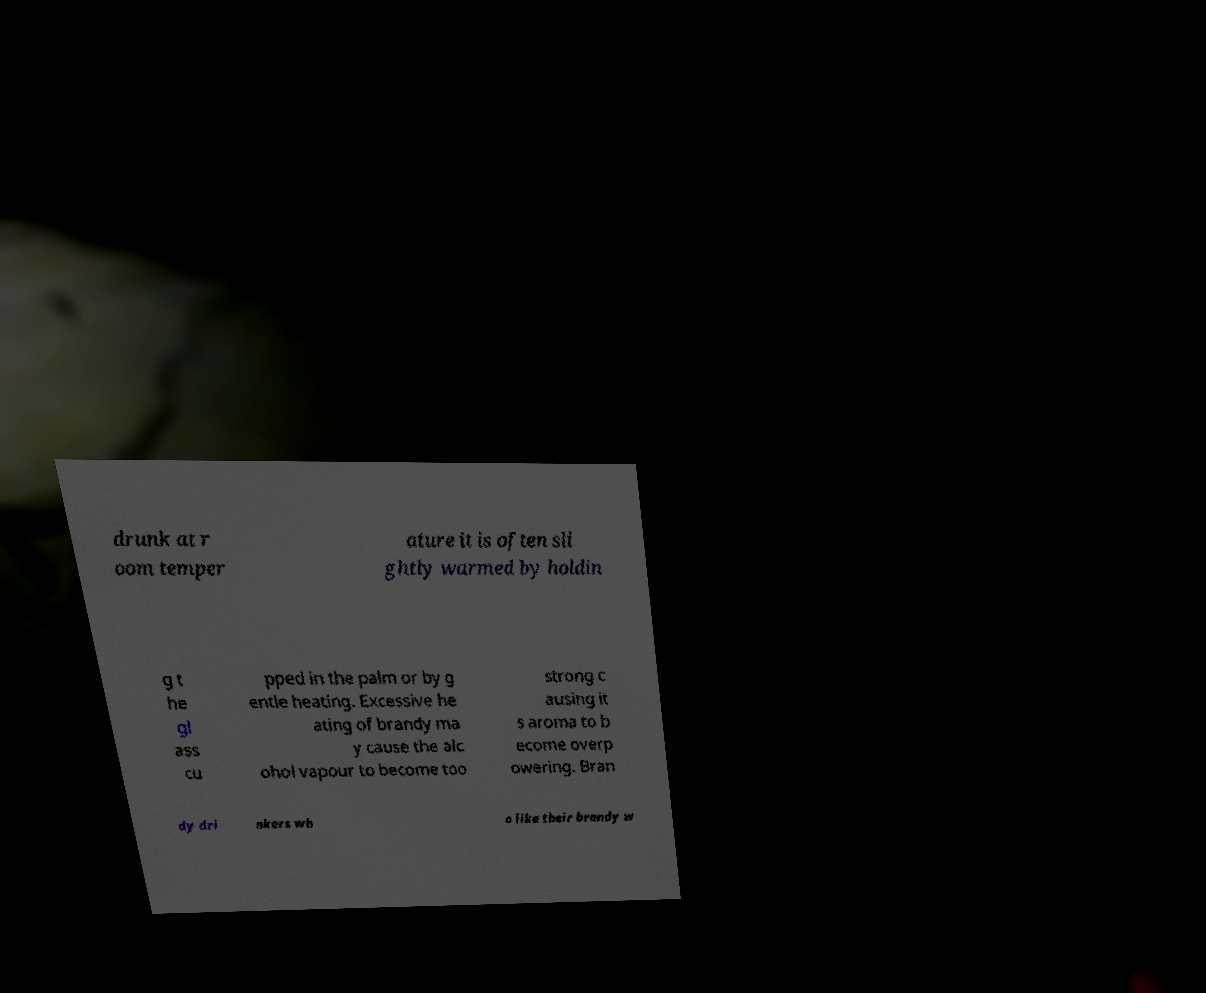For documentation purposes, I need the text within this image transcribed. Could you provide that? drunk at r oom temper ature it is often sli ghtly warmed by holdin g t he gl ass cu pped in the palm or by g entle heating. Excessive he ating of brandy ma y cause the alc ohol vapour to become too strong c ausing it s aroma to b ecome overp owering. Bran dy dri nkers wh o like their brandy w 